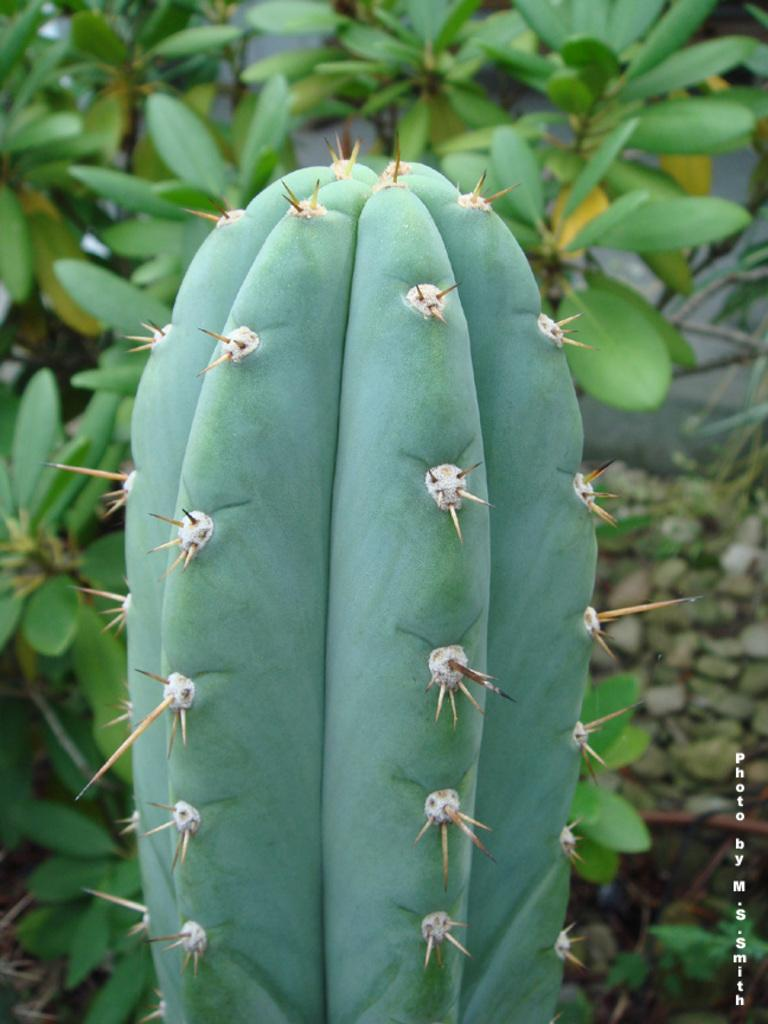What type of plant is the main subject in the image? There is a cactus in the image. What else can be seen in the background of the image? There are plants in the background of the image. Is there any text visible in the image? Yes, there is some text visible on the image. Can you tell me how much rice is being requested by the donkey in the image? There is no donkey or rice present in the image. 